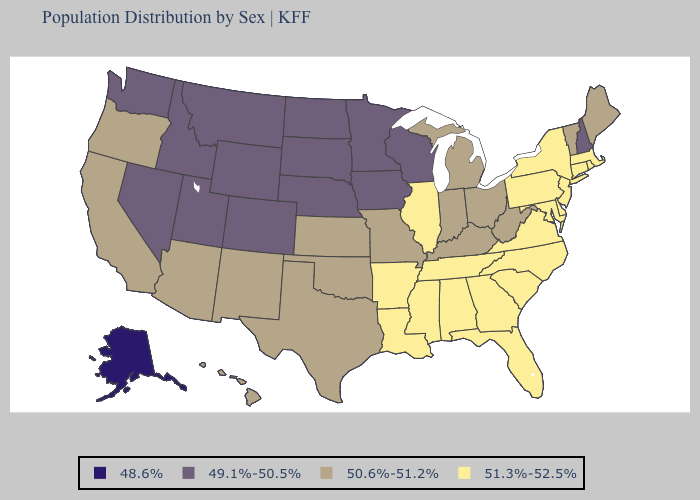Name the states that have a value in the range 50.6%-51.2%?
Short answer required. Arizona, California, Hawaii, Indiana, Kansas, Kentucky, Maine, Michigan, Missouri, New Mexico, Ohio, Oklahoma, Oregon, Texas, Vermont, West Virginia. Does the map have missing data?
Answer briefly. No. What is the value of Louisiana?
Answer briefly. 51.3%-52.5%. Does Arkansas have the same value as Kentucky?
Quick response, please. No. What is the value of Washington?
Write a very short answer. 49.1%-50.5%. Does Michigan have the same value as Kansas?
Quick response, please. Yes. What is the value of Hawaii?
Quick response, please. 50.6%-51.2%. Among the states that border New Mexico , does Texas have the highest value?
Give a very brief answer. Yes. What is the highest value in states that border New York?
Answer briefly. 51.3%-52.5%. Name the states that have a value in the range 48.6%?
Be succinct. Alaska. Does the first symbol in the legend represent the smallest category?
Write a very short answer. Yes. What is the lowest value in states that border Ohio?
Concise answer only. 50.6%-51.2%. Does the map have missing data?
Be succinct. No. Name the states that have a value in the range 48.6%?
Quick response, please. Alaska. 